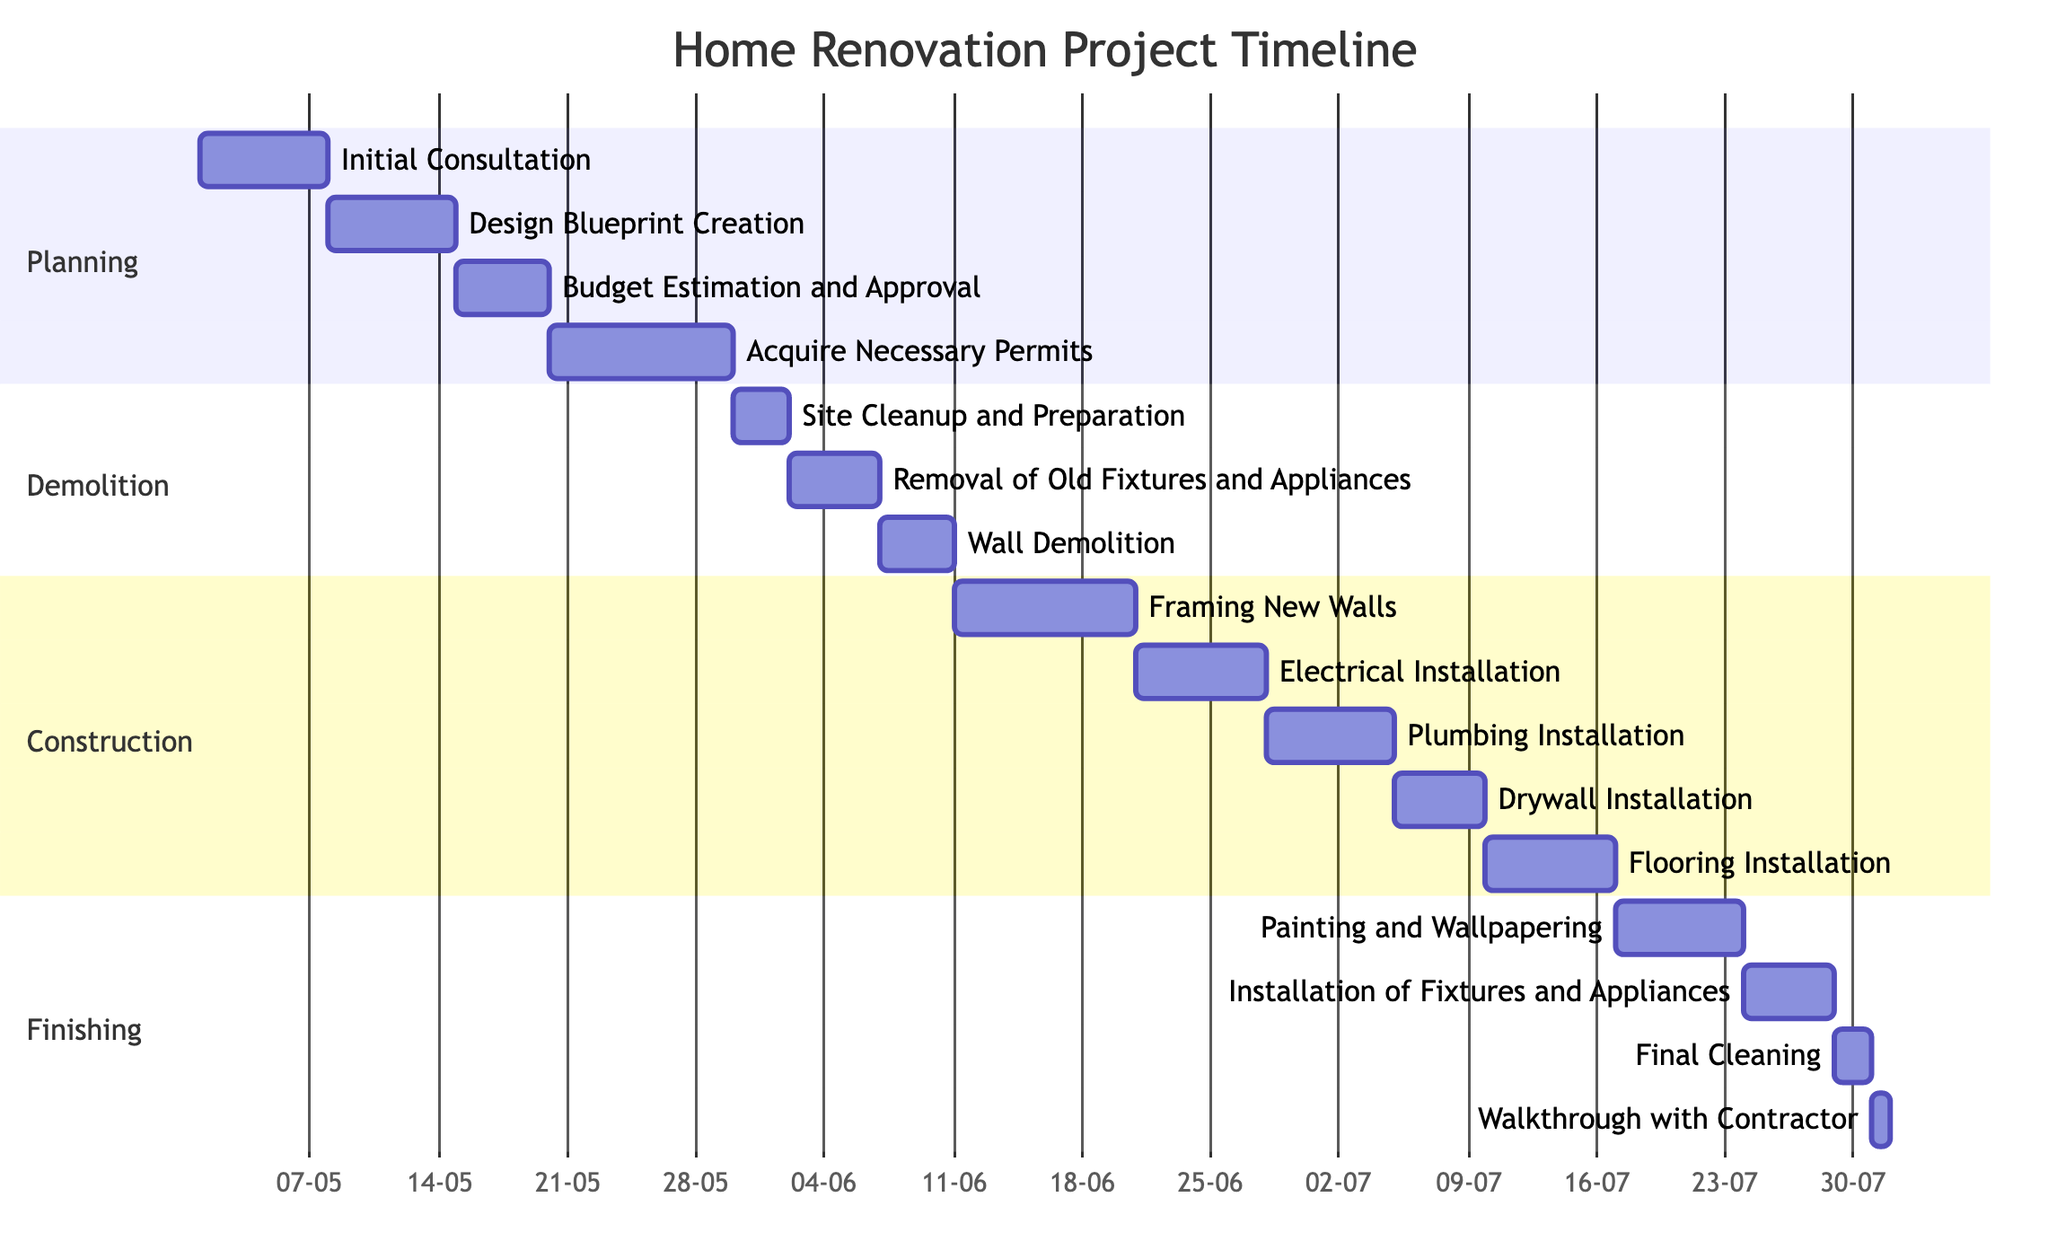What is the duration of the Planning phase? The Planning phase includes four activities with respective durations of 7, 14, 5, and 10 days. To find the total duration, I add these values: 7 + 14 + 5 + 10 = 36 days.
Answer: 36 days Which activity takes the longest in the Construction phase? In the Construction phase, the activities and their durations are as follows: 10 days for Framing New Walls, 7 days for Electrical Installation, 7 days for Plumbing Installation, 5 days for Drywall Installation, and 7 days for Flooring Installation. The maximum value here is 10 days for Framing New Walls.
Answer: Framing New Walls How many activities are there in the Demolition phase? The Demolition phase consists of three activities: Site Cleanup and Preparation, Removal of Old Fixtures and Appliances, and Wall Demolition. Counting these activities gives a total of 3.
Answer: 3 What is the total duration of the Finishing phase? The Finishing phase includes four activities with durations of 7, 5, 2, and 1 day. Adding them up: 7 + 5 + 2 + 1 = 15 days gives us the total duration.
Answer: 15 days Which phase has the shortest total duration? We calculate the total durations for each phase: Planning (36 days), Demolition (12 days), Construction (36 days), Finishing (15 days). Comparing these totals shows that Demolition, with 12 days, has the shortest duration.
Answer: Demolition What is the duration of the Painting and Wallpapering activity? The activity Painting and Wallpapering within the Finishing phase has a clearly indicated duration of 7 days in the diagram.
Answer: 7 days Which phase comes right after the Demolition phase? In the order of phases, the Demolition phase is followed by the Construction phase. Identifying the order involves looking at the sequence presented in the diagram.
Answer: Construction How many days does the Removal of Old Fixtures and Appliances activity take? According to the diagram, the duration specified for the Removal of Old Fixtures and Appliances activity in the Demolition phase is 5 days.
Answer: 5 days 